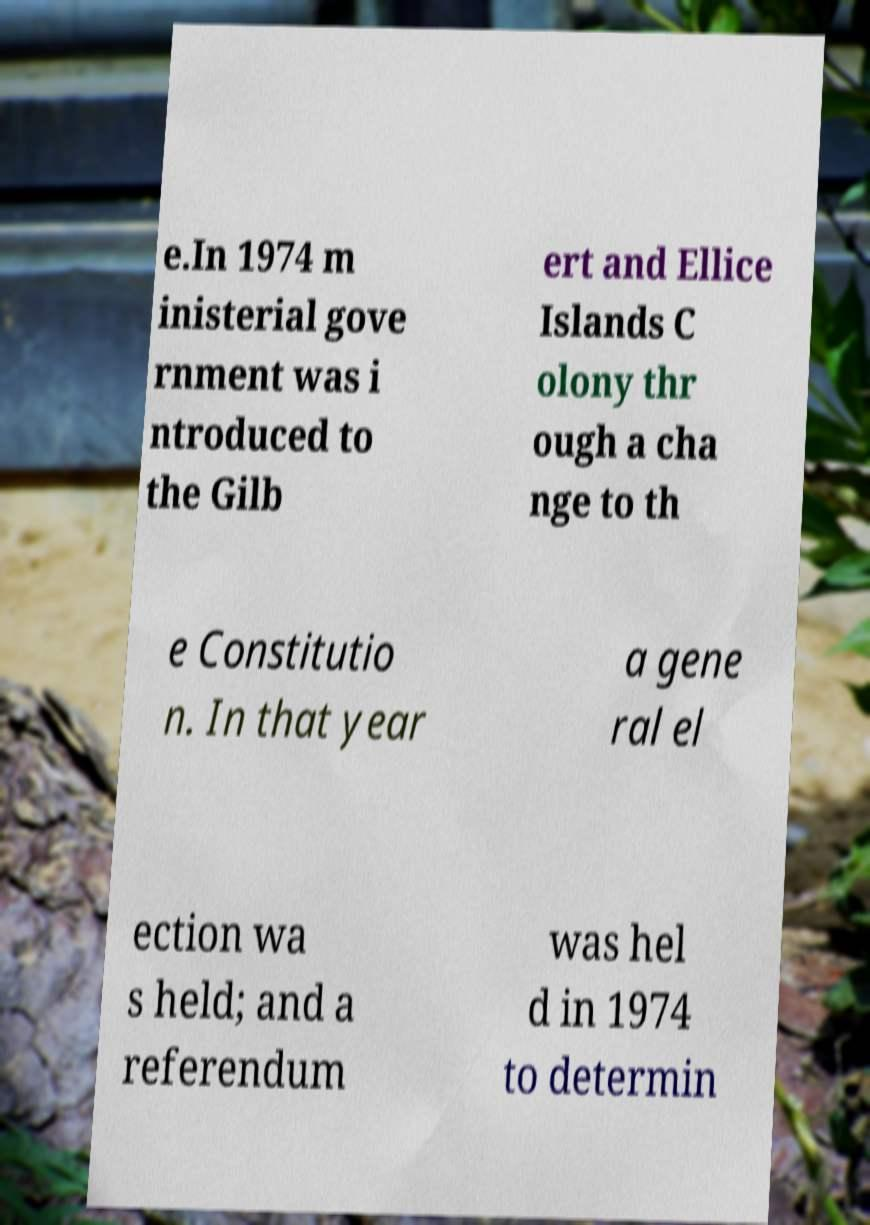Please identify and transcribe the text found in this image. e.In 1974 m inisterial gove rnment was i ntroduced to the Gilb ert and Ellice Islands C olony thr ough a cha nge to th e Constitutio n. In that year a gene ral el ection wa s held; and a referendum was hel d in 1974 to determin 